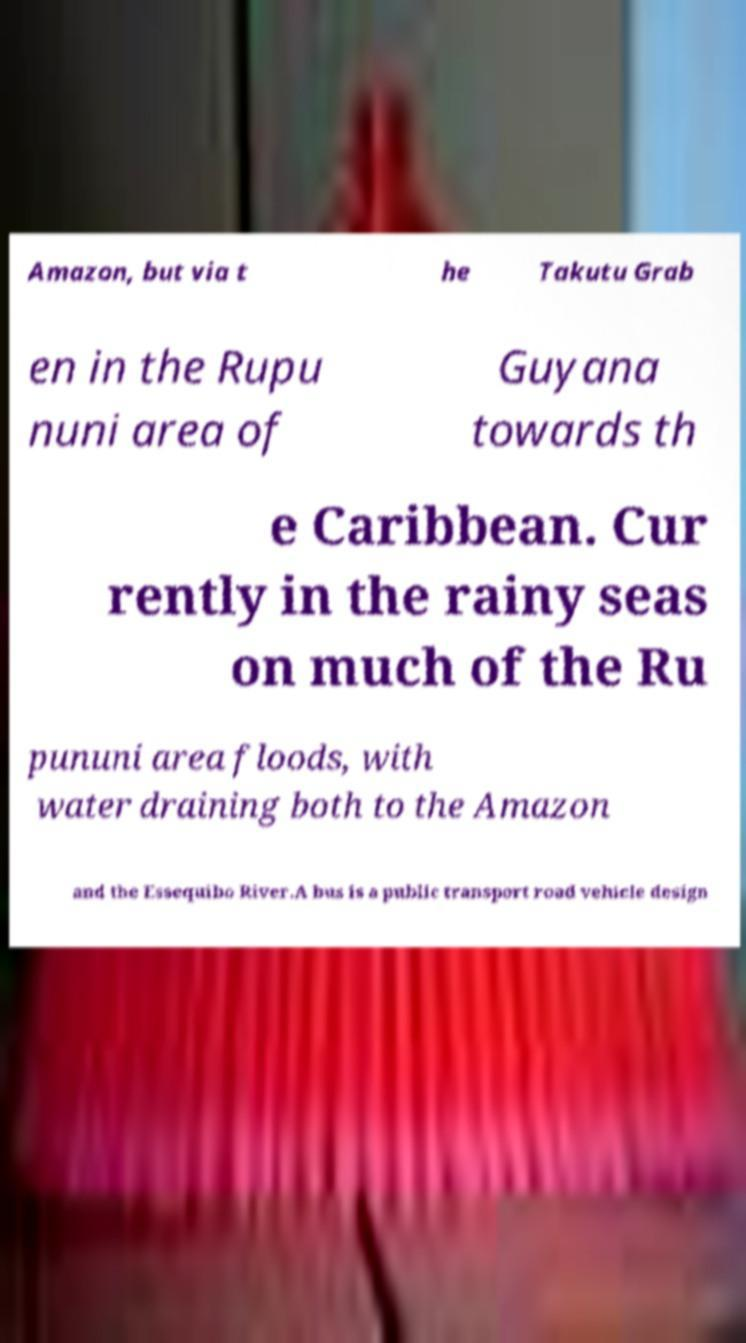Can you accurately transcribe the text from the provided image for me? Amazon, but via t he Takutu Grab en in the Rupu nuni area of Guyana towards th e Caribbean. Cur rently in the rainy seas on much of the Ru pununi area floods, with water draining both to the Amazon and the Essequibo River.A bus is a public transport road vehicle design 